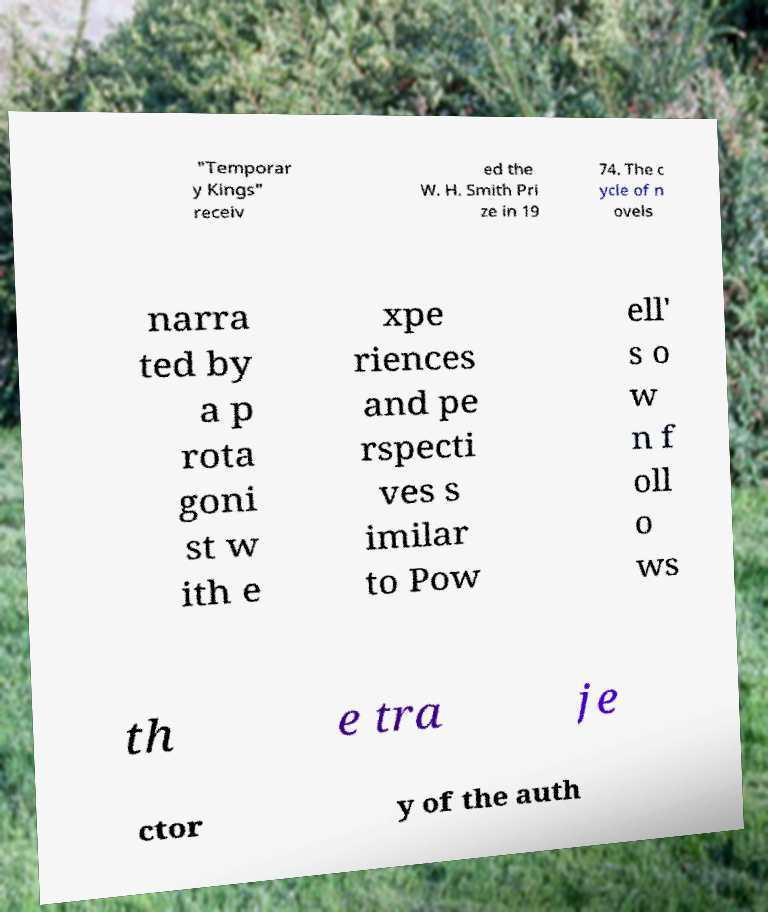Can you accurately transcribe the text from the provided image for me? "Temporar y Kings" receiv ed the W. H. Smith Pri ze in 19 74. The c ycle of n ovels narra ted by a p rota goni st w ith e xpe riences and pe rspecti ves s imilar to Pow ell' s o w n f oll o ws th e tra je ctor y of the auth 